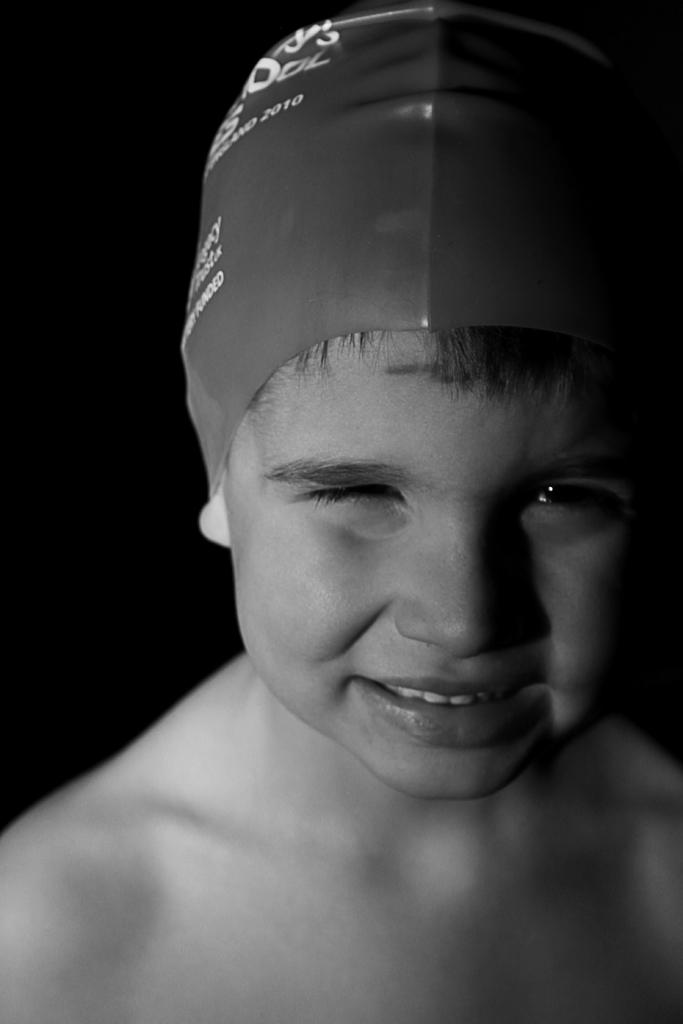What is the main subject of the image? There is a person in the image. Can you describe the background of the image? The background of the image is dark. What type of badge is the person wearing in the image? There is no badge visible in the image. How does the person express regret in the image? The image does not show any expression of regret, as there is no indication of the person's emotions or actions. 